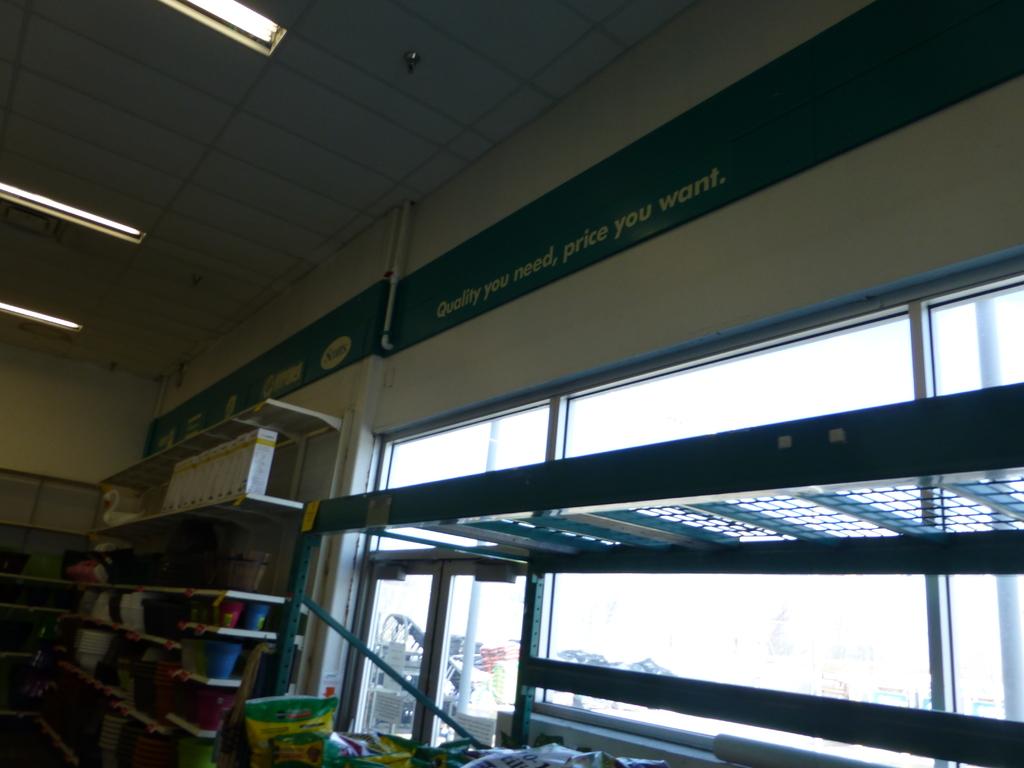What slogan is shown above the window?
Keep it short and to the point. Quality you need, price you want. 